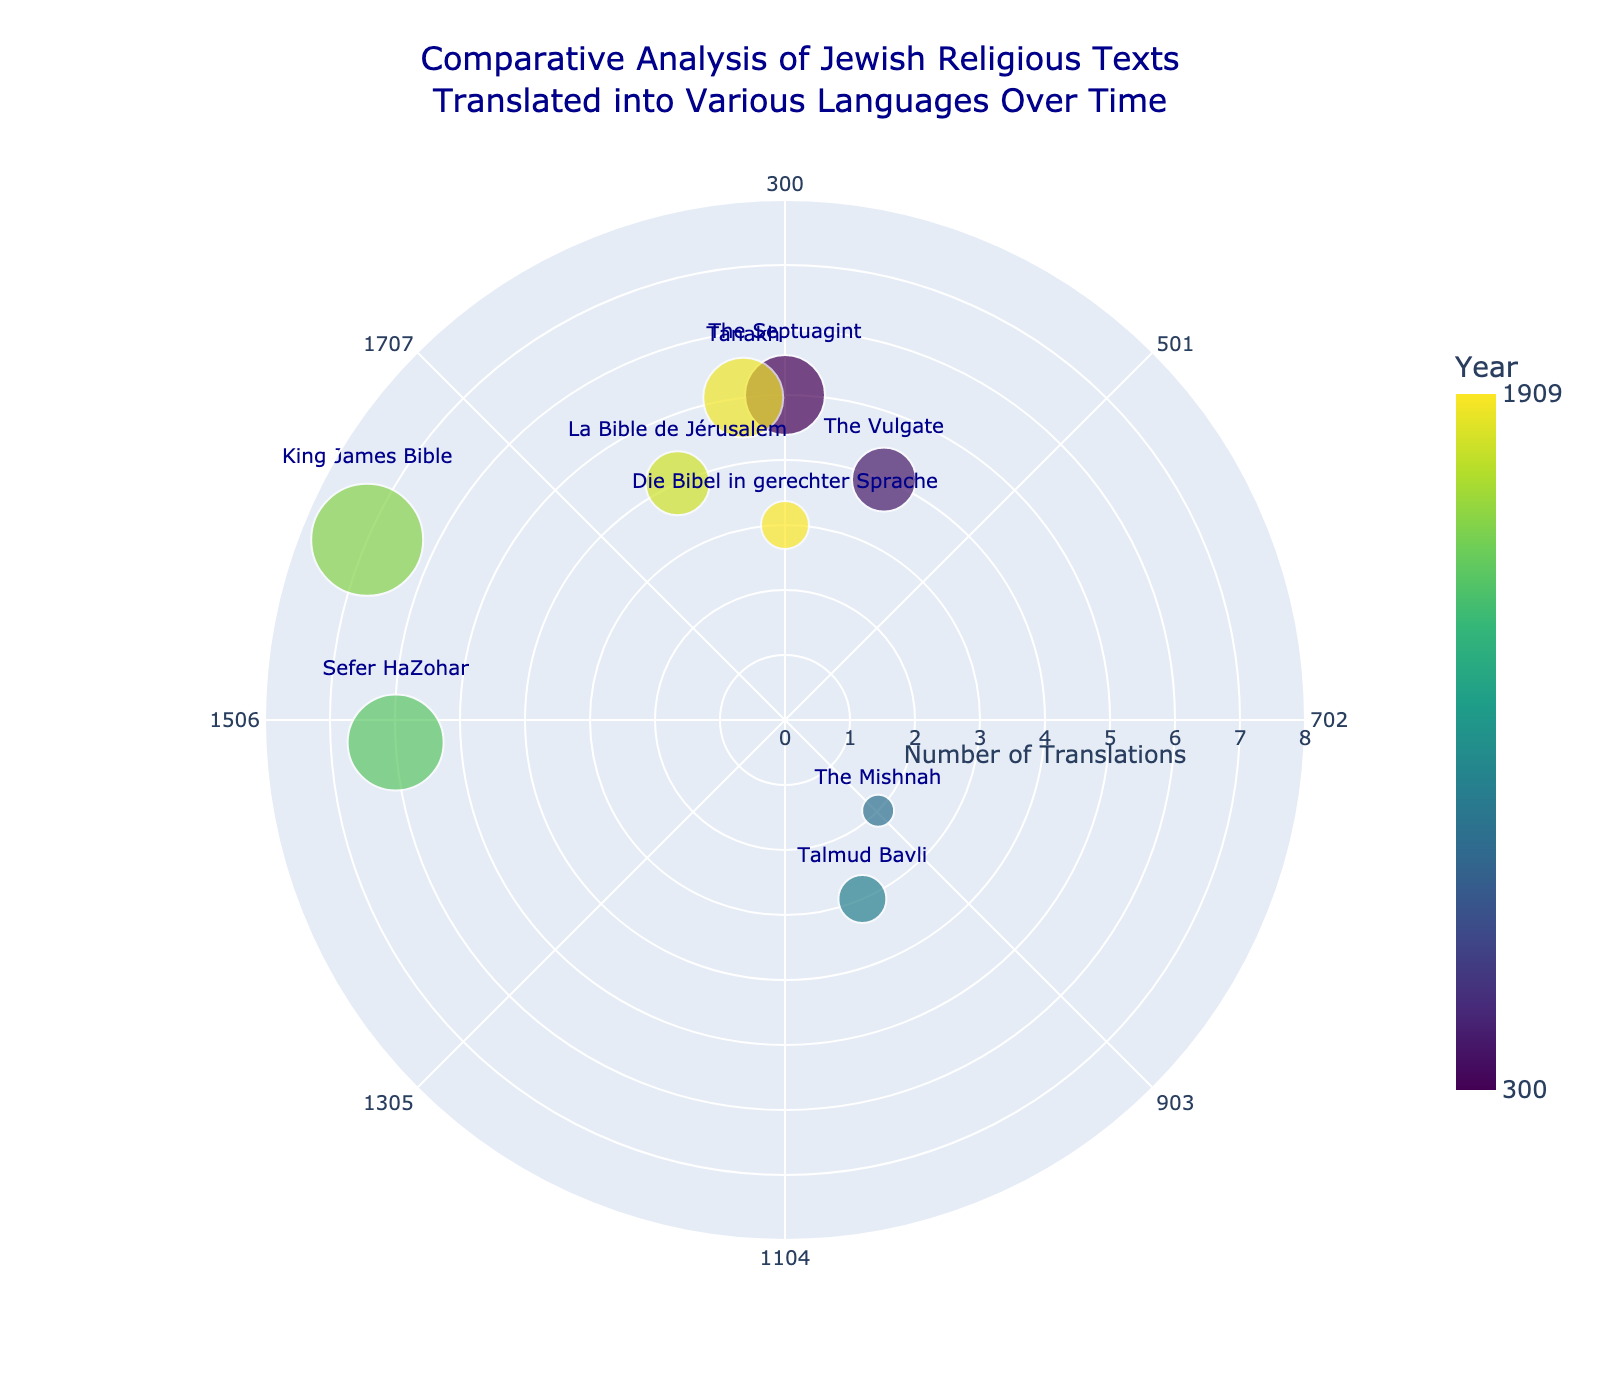What is the title of the figure? The title of the figure is displayed at the top and reads "Comparative Analysis of Jewish Religious Texts Translated into Various Languages Over Time".
Answer: Comparative Analysis of Jewish Religious Texts Translated into Various Languages Over Time Which text has the highest number of translations? By referring to the size of the markers and the labels, the "King James Bible" has the largest marker, indicating the highest number of translations, which is 7.
Answer: King James Bible What is the range of the 'year' axis on the polar chart? The 'year' axis ranges from the earliest year of 300 to the latest year of 1909 as shown by the labels around the angular axis.
Answer: 300 to 1909 Which language was used for the translation of "The Septuagint"? By looking at the markers and labels, the "The Septuagint" text is translated into Greek, shown next to the largest greenish-yellow marker.
Answer: Greek How many translations does "Die Bibel in gerechter Sprache" have? Referring to the size of the markers and labels, "Die Bibel in gerechter Sprache" has 3 translations.
Answer: 3 Which text was translated into Latin, and in what year? By checking the labels and hover information, "The Vulgate" was translated into Latin in the year 400.
Answer: The Vulgate, 400 How many translations in total were done after the year 1500? We need to count the radii (translation counts) after the year 1500: "Sefer HaZohar" (6), "King James Bible" (7), "La Bible de Jérusalem" (4), "Die Bibel in gerechter Sprache" (3), and "Tanakh" (5). Summing these up, we get 6 + 7 + 4 + 3 + 5 = 25.
Answer: 25 Which text has an equal number of translations as "Talmud Bavli"? "Talmud Bavli" has 3 translations. Checking the markers and labels, "Die Bibel in gerechter Sprache" also has 3 translations.
Answer: Die Bibel in gerechter Sprache Between "The Mishnah" and "La Bible de Jérusalem," which one has more translations, and by how many? "La Bible de Jérusalem" has 4 translations and "The Mishnah" has 2 translations. Therefore, "La Bible de Jérusalem" has more translations by 4 - 2 = 2.
Answer: La Bible de Jérusalem, by 2 How are the markers colored in the polar scatter chart? The markers are colored according to the year of translation, following a Viridis color scale where older texts have darker colors and newer texts have lighter colors.
Answer: By year using a Viridis color scale 